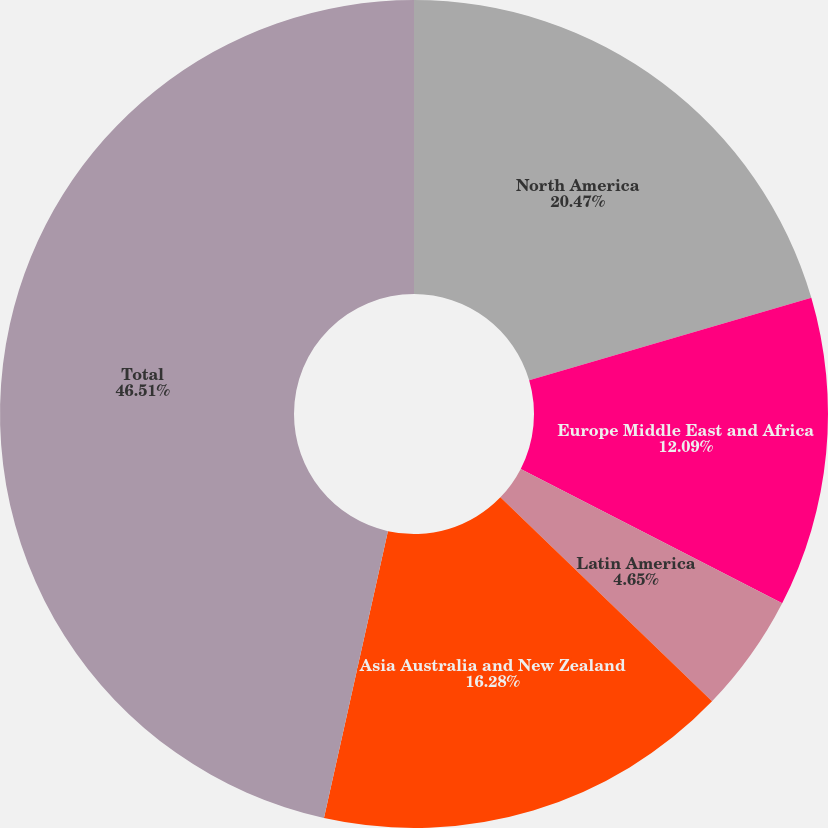Convert chart. <chart><loc_0><loc_0><loc_500><loc_500><pie_chart><fcel>North America<fcel>Europe Middle East and Africa<fcel>Latin America<fcel>Asia Australia and New Zealand<fcel>Total<nl><fcel>20.47%<fcel>12.09%<fcel>4.65%<fcel>16.28%<fcel>46.51%<nl></chart> 